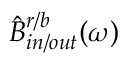<formula> <loc_0><loc_0><loc_500><loc_500>\hat { B } _ { i n / o u t } ^ { r / b } ( \omega )</formula> 